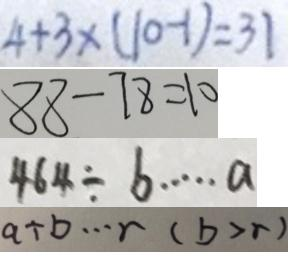<formula> <loc_0><loc_0><loc_500><loc_500>4 + 3 \times ( 1 0 - 1 ) = 3 1 
 8 8 - 7 8 = 1 0 
 4 6 4 \div b \cdots a 
 a \div b \cdots r ( b > r )</formula> 